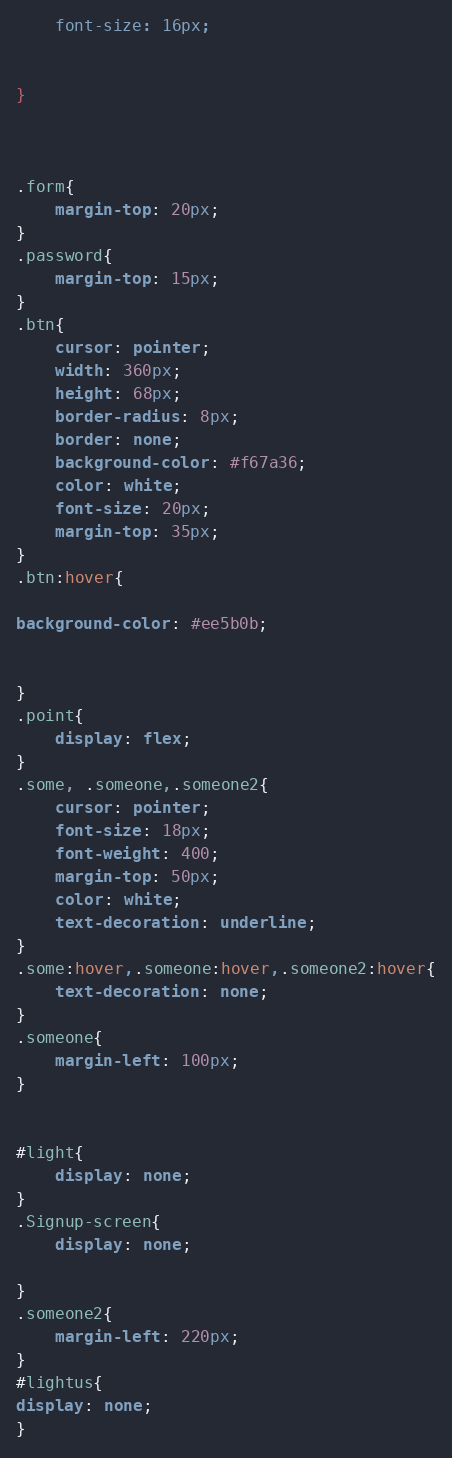Convert code to text. <code><loc_0><loc_0><loc_500><loc_500><_CSS_>    font-size: 16px;


}



.form{
    margin-top: 20px;
}
.password{
    margin-top: 15px;
}
.btn{
    cursor: pointer;
    width: 360px;
    height: 68px;
    border-radius: 8px;
    border: none;
    background-color: #f67a36;
    color: white;
    font-size: 20px;
    margin-top: 35px;
}
.btn:hover{

background-color: #ee5b0b;

    
}
.point{
    display: flex;
}
.some, .someone,.someone2{
    cursor: pointer;
    font-size: 18px;
    font-weight: 400;
    margin-top: 50px;
    color: white;
    text-decoration: underline;
}
.some:hover,.someone:hover,.someone2:hover{
    text-decoration: none;
}
.someone{
    margin-left: 100px;
}


#light{
    display: none;
}
.Signup-screen{
    display: none;

}
.someone2{
    margin-left: 220px;
}
#lightus{
display: none;
}

</code> 